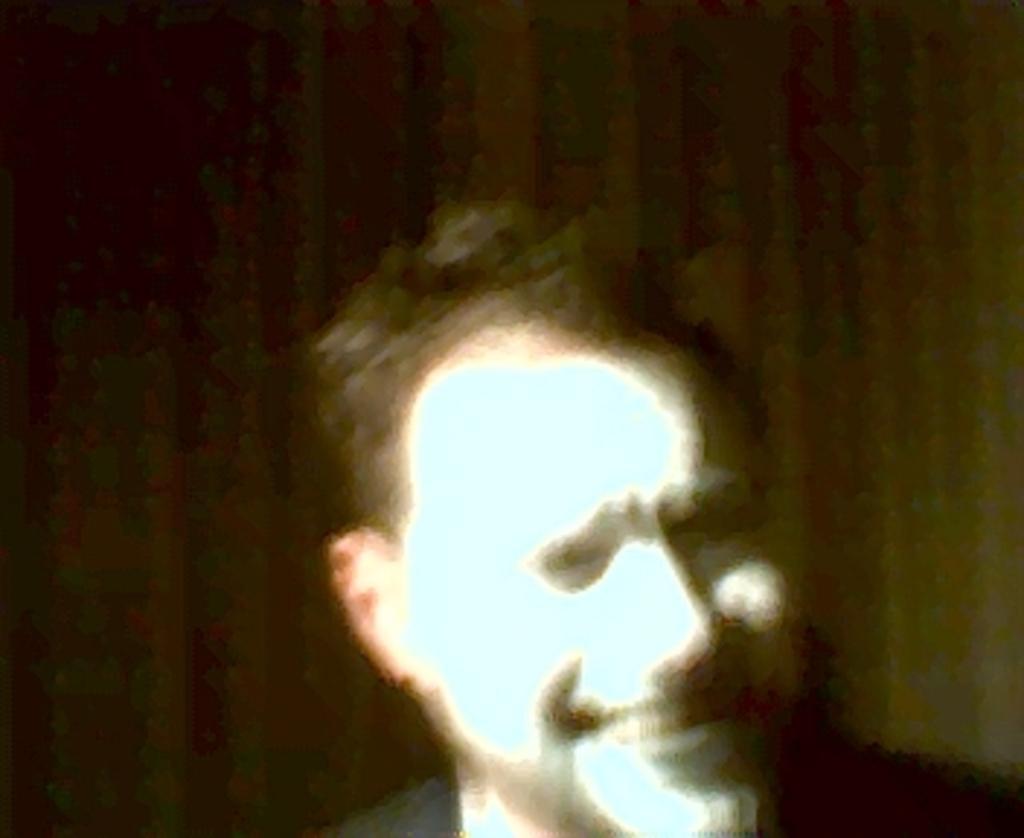Can you describe this image briefly? In this image there is a person truncated towards the bottom of the image, the background of the image is dark. 